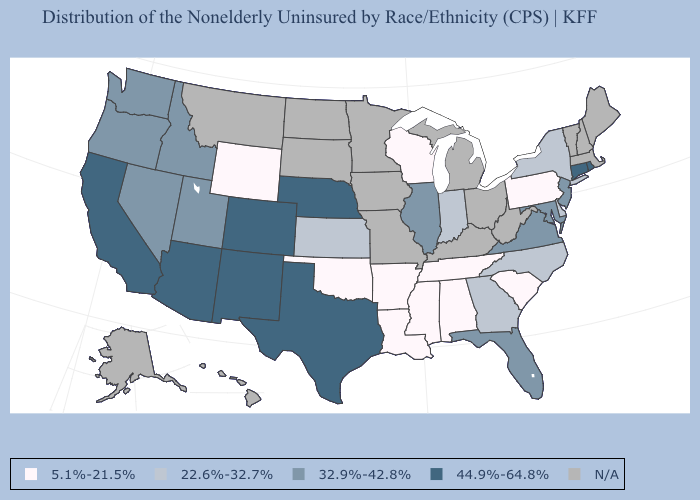What is the value of Nebraska?
Short answer required. 44.9%-64.8%. Name the states that have a value in the range 44.9%-64.8%?
Give a very brief answer. Arizona, California, Colorado, Connecticut, Nebraska, New Mexico, Rhode Island, Texas. Which states have the highest value in the USA?
Short answer required. Arizona, California, Colorado, Connecticut, Nebraska, New Mexico, Rhode Island, Texas. What is the value of Mississippi?
Quick response, please. 5.1%-21.5%. Name the states that have a value in the range 22.6%-32.7%?
Keep it brief. Delaware, Georgia, Indiana, Kansas, New York, North Carolina. Which states have the highest value in the USA?
Be succinct. Arizona, California, Colorado, Connecticut, Nebraska, New Mexico, Rhode Island, Texas. What is the value of Massachusetts?
Quick response, please. N/A. Does the map have missing data?
Quick response, please. Yes. What is the value of Virginia?
Write a very short answer. 32.9%-42.8%. Does the first symbol in the legend represent the smallest category?
Be succinct. Yes. Does Georgia have the lowest value in the South?
Give a very brief answer. No. What is the highest value in the Northeast ?
Write a very short answer. 44.9%-64.8%. What is the value of Nebraska?
Answer briefly. 44.9%-64.8%. Name the states that have a value in the range N/A?
Write a very short answer. Alaska, Hawaii, Iowa, Kentucky, Maine, Massachusetts, Michigan, Minnesota, Missouri, Montana, New Hampshire, North Dakota, Ohio, South Dakota, Vermont, West Virginia. 